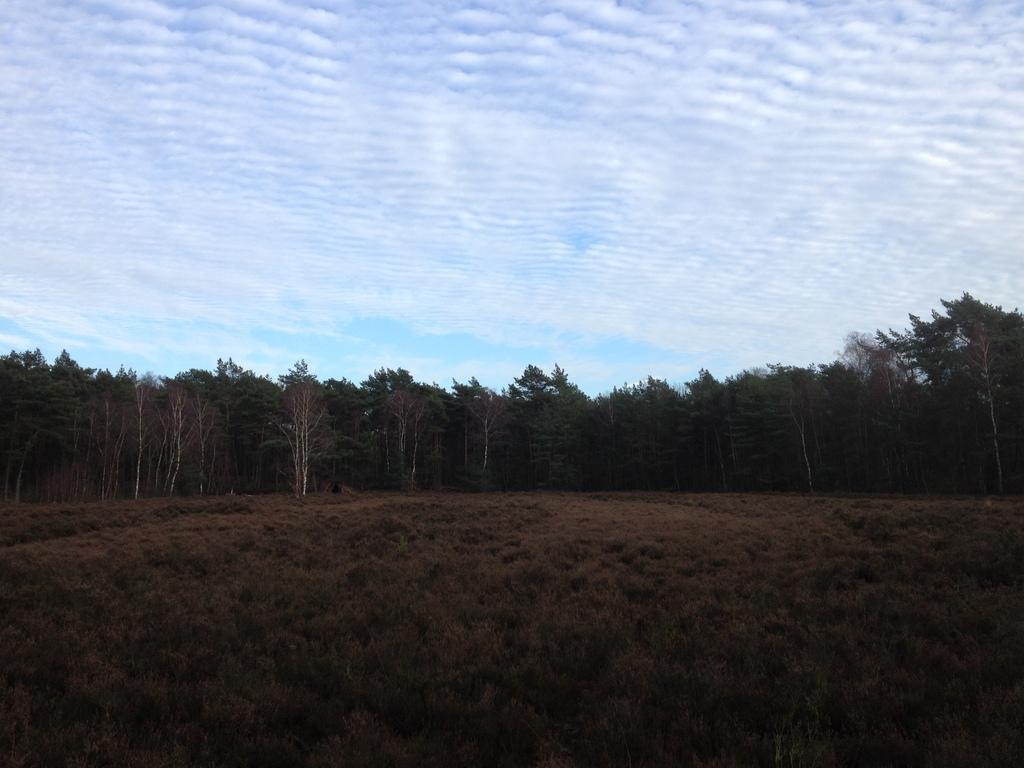How would you summarize this image in a sentence or two? In this image, we can see some grass. There are trees in the middle of the image. There is a sky at the top of the image. 